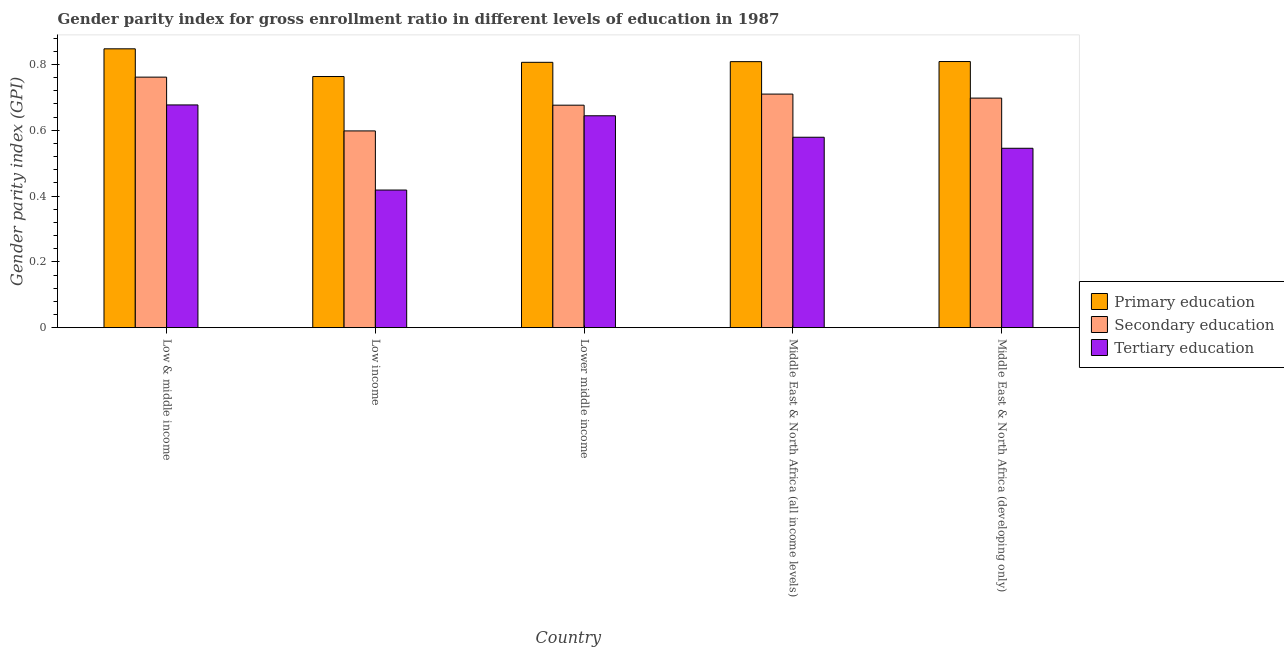How many different coloured bars are there?
Your answer should be very brief. 3. Are the number of bars per tick equal to the number of legend labels?
Your answer should be very brief. Yes. What is the label of the 3rd group of bars from the left?
Your answer should be very brief. Lower middle income. What is the gender parity index in secondary education in Low income?
Give a very brief answer. 0.6. Across all countries, what is the maximum gender parity index in secondary education?
Give a very brief answer. 0.76. Across all countries, what is the minimum gender parity index in secondary education?
Your answer should be very brief. 0.6. In which country was the gender parity index in tertiary education maximum?
Your answer should be very brief. Low & middle income. What is the total gender parity index in primary education in the graph?
Ensure brevity in your answer.  4.03. What is the difference between the gender parity index in primary education in Low income and that in Middle East & North Africa (all income levels)?
Keep it short and to the point. -0.05. What is the difference between the gender parity index in secondary education in Lower middle income and the gender parity index in tertiary education in Middle East & North Africa (developing only)?
Your answer should be very brief. 0.13. What is the average gender parity index in tertiary education per country?
Keep it short and to the point. 0.57. What is the difference between the gender parity index in secondary education and gender parity index in tertiary education in Low & middle income?
Provide a succinct answer. 0.08. In how many countries, is the gender parity index in primary education greater than 0.24000000000000002 ?
Ensure brevity in your answer.  5. What is the ratio of the gender parity index in secondary education in Low & middle income to that in Low income?
Your answer should be very brief. 1.27. Is the gender parity index in tertiary education in Lower middle income less than that in Middle East & North Africa (developing only)?
Give a very brief answer. No. Is the difference between the gender parity index in secondary education in Low income and Middle East & North Africa (developing only) greater than the difference between the gender parity index in tertiary education in Low income and Middle East & North Africa (developing only)?
Offer a very short reply. Yes. What is the difference between the highest and the second highest gender parity index in secondary education?
Make the answer very short. 0.05. What is the difference between the highest and the lowest gender parity index in primary education?
Provide a succinct answer. 0.08. What does the 2nd bar from the left in Low income represents?
Offer a terse response. Secondary education. What does the 2nd bar from the right in Middle East & North Africa (developing only) represents?
Keep it short and to the point. Secondary education. Is it the case that in every country, the sum of the gender parity index in primary education and gender parity index in secondary education is greater than the gender parity index in tertiary education?
Provide a short and direct response. Yes. Are all the bars in the graph horizontal?
Keep it short and to the point. No. What is the difference between two consecutive major ticks on the Y-axis?
Ensure brevity in your answer.  0.2. Does the graph contain any zero values?
Give a very brief answer. No. Where does the legend appear in the graph?
Your response must be concise. Center right. What is the title of the graph?
Ensure brevity in your answer.  Gender parity index for gross enrollment ratio in different levels of education in 1987. What is the label or title of the X-axis?
Your answer should be very brief. Country. What is the label or title of the Y-axis?
Offer a terse response. Gender parity index (GPI). What is the Gender parity index (GPI) of Primary education in Low & middle income?
Provide a short and direct response. 0.85. What is the Gender parity index (GPI) of Secondary education in Low & middle income?
Your response must be concise. 0.76. What is the Gender parity index (GPI) in Tertiary education in Low & middle income?
Offer a terse response. 0.68. What is the Gender parity index (GPI) in Primary education in Low income?
Your answer should be very brief. 0.76. What is the Gender parity index (GPI) in Secondary education in Low income?
Offer a very short reply. 0.6. What is the Gender parity index (GPI) in Tertiary education in Low income?
Provide a short and direct response. 0.42. What is the Gender parity index (GPI) in Primary education in Lower middle income?
Your answer should be compact. 0.81. What is the Gender parity index (GPI) of Secondary education in Lower middle income?
Give a very brief answer. 0.68. What is the Gender parity index (GPI) in Tertiary education in Lower middle income?
Offer a very short reply. 0.64. What is the Gender parity index (GPI) of Primary education in Middle East & North Africa (all income levels)?
Give a very brief answer. 0.81. What is the Gender parity index (GPI) of Secondary education in Middle East & North Africa (all income levels)?
Your answer should be compact. 0.71. What is the Gender parity index (GPI) in Tertiary education in Middle East & North Africa (all income levels)?
Offer a terse response. 0.58. What is the Gender parity index (GPI) in Primary education in Middle East & North Africa (developing only)?
Your answer should be very brief. 0.81. What is the Gender parity index (GPI) of Secondary education in Middle East & North Africa (developing only)?
Your response must be concise. 0.7. What is the Gender parity index (GPI) in Tertiary education in Middle East & North Africa (developing only)?
Offer a terse response. 0.55. Across all countries, what is the maximum Gender parity index (GPI) of Primary education?
Offer a terse response. 0.85. Across all countries, what is the maximum Gender parity index (GPI) of Secondary education?
Your response must be concise. 0.76. Across all countries, what is the maximum Gender parity index (GPI) in Tertiary education?
Provide a short and direct response. 0.68. Across all countries, what is the minimum Gender parity index (GPI) in Primary education?
Make the answer very short. 0.76. Across all countries, what is the minimum Gender parity index (GPI) in Secondary education?
Provide a short and direct response. 0.6. Across all countries, what is the minimum Gender parity index (GPI) in Tertiary education?
Ensure brevity in your answer.  0.42. What is the total Gender parity index (GPI) in Primary education in the graph?
Offer a very short reply. 4.03. What is the total Gender parity index (GPI) in Secondary education in the graph?
Provide a short and direct response. 3.44. What is the total Gender parity index (GPI) of Tertiary education in the graph?
Provide a succinct answer. 2.86. What is the difference between the Gender parity index (GPI) in Primary education in Low & middle income and that in Low income?
Your response must be concise. 0.08. What is the difference between the Gender parity index (GPI) in Secondary education in Low & middle income and that in Low income?
Offer a very short reply. 0.16. What is the difference between the Gender parity index (GPI) of Tertiary education in Low & middle income and that in Low income?
Offer a terse response. 0.26. What is the difference between the Gender parity index (GPI) of Primary education in Low & middle income and that in Lower middle income?
Offer a terse response. 0.04. What is the difference between the Gender parity index (GPI) of Secondary education in Low & middle income and that in Lower middle income?
Ensure brevity in your answer.  0.09. What is the difference between the Gender parity index (GPI) in Tertiary education in Low & middle income and that in Lower middle income?
Your response must be concise. 0.03. What is the difference between the Gender parity index (GPI) of Primary education in Low & middle income and that in Middle East & North Africa (all income levels)?
Provide a short and direct response. 0.04. What is the difference between the Gender parity index (GPI) of Secondary education in Low & middle income and that in Middle East & North Africa (all income levels)?
Give a very brief answer. 0.05. What is the difference between the Gender parity index (GPI) of Tertiary education in Low & middle income and that in Middle East & North Africa (all income levels)?
Your answer should be very brief. 0.1. What is the difference between the Gender parity index (GPI) of Primary education in Low & middle income and that in Middle East & North Africa (developing only)?
Your answer should be compact. 0.04. What is the difference between the Gender parity index (GPI) of Secondary education in Low & middle income and that in Middle East & North Africa (developing only)?
Provide a succinct answer. 0.06. What is the difference between the Gender parity index (GPI) in Tertiary education in Low & middle income and that in Middle East & North Africa (developing only)?
Make the answer very short. 0.13. What is the difference between the Gender parity index (GPI) in Primary education in Low income and that in Lower middle income?
Your answer should be very brief. -0.04. What is the difference between the Gender parity index (GPI) in Secondary education in Low income and that in Lower middle income?
Make the answer very short. -0.08. What is the difference between the Gender parity index (GPI) of Tertiary education in Low income and that in Lower middle income?
Ensure brevity in your answer.  -0.23. What is the difference between the Gender parity index (GPI) in Primary education in Low income and that in Middle East & North Africa (all income levels)?
Your answer should be very brief. -0.05. What is the difference between the Gender parity index (GPI) in Secondary education in Low income and that in Middle East & North Africa (all income levels)?
Give a very brief answer. -0.11. What is the difference between the Gender parity index (GPI) in Tertiary education in Low income and that in Middle East & North Africa (all income levels)?
Provide a short and direct response. -0.16. What is the difference between the Gender parity index (GPI) of Primary education in Low income and that in Middle East & North Africa (developing only)?
Your answer should be very brief. -0.05. What is the difference between the Gender parity index (GPI) of Secondary education in Low income and that in Middle East & North Africa (developing only)?
Provide a short and direct response. -0.1. What is the difference between the Gender parity index (GPI) of Tertiary education in Low income and that in Middle East & North Africa (developing only)?
Offer a very short reply. -0.13. What is the difference between the Gender parity index (GPI) of Primary education in Lower middle income and that in Middle East & North Africa (all income levels)?
Your answer should be compact. -0. What is the difference between the Gender parity index (GPI) in Secondary education in Lower middle income and that in Middle East & North Africa (all income levels)?
Provide a succinct answer. -0.03. What is the difference between the Gender parity index (GPI) in Tertiary education in Lower middle income and that in Middle East & North Africa (all income levels)?
Ensure brevity in your answer.  0.07. What is the difference between the Gender parity index (GPI) in Primary education in Lower middle income and that in Middle East & North Africa (developing only)?
Ensure brevity in your answer.  -0. What is the difference between the Gender parity index (GPI) of Secondary education in Lower middle income and that in Middle East & North Africa (developing only)?
Provide a succinct answer. -0.02. What is the difference between the Gender parity index (GPI) of Tertiary education in Lower middle income and that in Middle East & North Africa (developing only)?
Your answer should be very brief. 0.1. What is the difference between the Gender parity index (GPI) in Primary education in Middle East & North Africa (all income levels) and that in Middle East & North Africa (developing only)?
Give a very brief answer. -0. What is the difference between the Gender parity index (GPI) in Secondary education in Middle East & North Africa (all income levels) and that in Middle East & North Africa (developing only)?
Offer a terse response. 0.01. What is the difference between the Gender parity index (GPI) of Tertiary education in Middle East & North Africa (all income levels) and that in Middle East & North Africa (developing only)?
Offer a very short reply. 0.03. What is the difference between the Gender parity index (GPI) of Primary education in Low & middle income and the Gender parity index (GPI) of Secondary education in Low income?
Offer a terse response. 0.25. What is the difference between the Gender parity index (GPI) of Primary education in Low & middle income and the Gender parity index (GPI) of Tertiary education in Low income?
Your response must be concise. 0.43. What is the difference between the Gender parity index (GPI) of Secondary education in Low & middle income and the Gender parity index (GPI) of Tertiary education in Low income?
Give a very brief answer. 0.34. What is the difference between the Gender parity index (GPI) of Primary education in Low & middle income and the Gender parity index (GPI) of Secondary education in Lower middle income?
Your answer should be compact. 0.17. What is the difference between the Gender parity index (GPI) in Primary education in Low & middle income and the Gender parity index (GPI) in Tertiary education in Lower middle income?
Your response must be concise. 0.2. What is the difference between the Gender parity index (GPI) in Secondary education in Low & middle income and the Gender parity index (GPI) in Tertiary education in Lower middle income?
Give a very brief answer. 0.12. What is the difference between the Gender parity index (GPI) of Primary education in Low & middle income and the Gender parity index (GPI) of Secondary education in Middle East & North Africa (all income levels)?
Your answer should be compact. 0.14. What is the difference between the Gender parity index (GPI) of Primary education in Low & middle income and the Gender parity index (GPI) of Tertiary education in Middle East & North Africa (all income levels)?
Provide a short and direct response. 0.27. What is the difference between the Gender parity index (GPI) of Secondary education in Low & middle income and the Gender parity index (GPI) of Tertiary education in Middle East & North Africa (all income levels)?
Offer a terse response. 0.18. What is the difference between the Gender parity index (GPI) in Primary education in Low & middle income and the Gender parity index (GPI) in Secondary education in Middle East & North Africa (developing only)?
Ensure brevity in your answer.  0.15. What is the difference between the Gender parity index (GPI) in Primary education in Low & middle income and the Gender parity index (GPI) in Tertiary education in Middle East & North Africa (developing only)?
Give a very brief answer. 0.3. What is the difference between the Gender parity index (GPI) of Secondary education in Low & middle income and the Gender parity index (GPI) of Tertiary education in Middle East & North Africa (developing only)?
Your answer should be very brief. 0.22. What is the difference between the Gender parity index (GPI) in Primary education in Low income and the Gender parity index (GPI) in Secondary education in Lower middle income?
Your answer should be compact. 0.09. What is the difference between the Gender parity index (GPI) in Primary education in Low income and the Gender parity index (GPI) in Tertiary education in Lower middle income?
Provide a succinct answer. 0.12. What is the difference between the Gender parity index (GPI) of Secondary education in Low income and the Gender parity index (GPI) of Tertiary education in Lower middle income?
Make the answer very short. -0.05. What is the difference between the Gender parity index (GPI) in Primary education in Low income and the Gender parity index (GPI) in Secondary education in Middle East & North Africa (all income levels)?
Provide a short and direct response. 0.05. What is the difference between the Gender parity index (GPI) in Primary education in Low income and the Gender parity index (GPI) in Tertiary education in Middle East & North Africa (all income levels)?
Offer a very short reply. 0.18. What is the difference between the Gender parity index (GPI) of Secondary education in Low income and the Gender parity index (GPI) of Tertiary education in Middle East & North Africa (all income levels)?
Keep it short and to the point. 0.02. What is the difference between the Gender parity index (GPI) in Primary education in Low income and the Gender parity index (GPI) in Secondary education in Middle East & North Africa (developing only)?
Offer a very short reply. 0.07. What is the difference between the Gender parity index (GPI) of Primary education in Low income and the Gender parity index (GPI) of Tertiary education in Middle East & North Africa (developing only)?
Keep it short and to the point. 0.22. What is the difference between the Gender parity index (GPI) in Secondary education in Low income and the Gender parity index (GPI) in Tertiary education in Middle East & North Africa (developing only)?
Keep it short and to the point. 0.05. What is the difference between the Gender parity index (GPI) of Primary education in Lower middle income and the Gender parity index (GPI) of Secondary education in Middle East & North Africa (all income levels)?
Make the answer very short. 0.1. What is the difference between the Gender parity index (GPI) in Primary education in Lower middle income and the Gender parity index (GPI) in Tertiary education in Middle East & North Africa (all income levels)?
Your answer should be compact. 0.23. What is the difference between the Gender parity index (GPI) of Secondary education in Lower middle income and the Gender parity index (GPI) of Tertiary education in Middle East & North Africa (all income levels)?
Keep it short and to the point. 0.1. What is the difference between the Gender parity index (GPI) of Primary education in Lower middle income and the Gender parity index (GPI) of Secondary education in Middle East & North Africa (developing only)?
Ensure brevity in your answer.  0.11. What is the difference between the Gender parity index (GPI) in Primary education in Lower middle income and the Gender parity index (GPI) in Tertiary education in Middle East & North Africa (developing only)?
Provide a succinct answer. 0.26. What is the difference between the Gender parity index (GPI) of Secondary education in Lower middle income and the Gender parity index (GPI) of Tertiary education in Middle East & North Africa (developing only)?
Your response must be concise. 0.13. What is the difference between the Gender parity index (GPI) of Primary education in Middle East & North Africa (all income levels) and the Gender parity index (GPI) of Secondary education in Middle East & North Africa (developing only)?
Provide a short and direct response. 0.11. What is the difference between the Gender parity index (GPI) in Primary education in Middle East & North Africa (all income levels) and the Gender parity index (GPI) in Tertiary education in Middle East & North Africa (developing only)?
Provide a succinct answer. 0.26. What is the difference between the Gender parity index (GPI) in Secondary education in Middle East & North Africa (all income levels) and the Gender parity index (GPI) in Tertiary education in Middle East & North Africa (developing only)?
Ensure brevity in your answer.  0.16. What is the average Gender parity index (GPI) of Primary education per country?
Ensure brevity in your answer.  0.81. What is the average Gender parity index (GPI) in Secondary education per country?
Provide a short and direct response. 0.69. What is the average Gender parity index (GPI) in Tertiary education per country?
Provide a short and direct response. 0.57. What is the difference between the Gender parity index (GPI) in Primary education and Gender parity index (GPI) in Secondary education in Low & middle income?
Make the answer very short. 0.09. What is the difference between the Gender parity index (GPI) in Primary education and Gender parity index (GPI) in Tertiary education in Low & middle income?
Provide a short and direct response. 0.17. What is the difference between the Gender parity index (GPI) of Secondary education and Gender parity index (GPI) of Tertiary education in Low & middle income?
Offer a very short reply. 0.08. What is the difference between the Gender parity index (GPI) in Primary education and Gender parity index (GPI) in Secondary education in Low income?
Offer a very short reply. 0.17. What is the difference between the Gender parity index (GPI) of Primary education and Gender parity index (GPI) of Tertiary education in Low income?
Provide a succinct answer. 0.34. What is the difference between the Gender parity index (GPI) in Secondary education and Gender parity index (GPI) in Tertiary education in Low income?
Your answer should be compact. 0.18. What is the difference between the Gender parity index (GPI) in Primary education and Gender parity index (GPI) in Secondary education in Lower middle income?
Your answer should be very brief. 0.13. What is the difference between the Gender parity index (GPI) of Primary education and Gender parity index (GPI) of Tertiary education in Lower middle income?
Offer a very short reply. 0.16. What is the difference between the Gender parity index (GPI) in Secondary education and Gender parity index (GPI) in Tertiary education in Lower middle income?
Your answer should be very brief. 0.03. What is the difference between the Gender parity index (GPI) of Primary education and Gender parity index (GPI) of Secondary education in Middle East & North Africa (all income levels)?
Make the answer very short. 0.1. What is the difference between the Gender parity index (GPI) of Primary education and Gender parity index (GPI) of Tertiary education in Middle East & North Africa (all income levels)?
Provide a succinct answer. 0.23. What is the difference between the Gender parity index (GPI) of Secondary education and Gender parity index (GPI) of Tertiary education in Middle East & North Africa (all income levels)?
Offer a very short reply. 0.13. What is the difference between the Gender parity index (GPI) in Primary education and Gender parity index (GPI) in Secondary education in Middle East & North Africa (developing only)?
Give a very brief answer. 0.11. What is the difference between the Gender parity index (GPI) in Primary education and Gender parity index (GPI) in Tertiary education in Middle East & North Africa (developing only)?
Ensure brevity in your answer.  0.26. What is the difference between the Gender parity index (GPI) of Secondary education and Gender parity index (GPI) of Tertiary education in Middle East & North Africa (developing only)?
Your answer should be very brief. 0.15. What is the ratio of the Gender parity index (GPI) in Primary education in Low & middle income to that in Low income?
Make the answer very short. 1.11. What is the ratio of the Gender parity index (GPI) of Secondary education in Low & middle income to that in Low income?
Offer a very short reply. 1.27. What is the ratio of the Gender parity index (GPI) in Tertiary education in Low & middle income to that in Low income?
Offer a terse response. 1.62. What is the ratio of the Gender parity index (GPI) in Primary education in Low & middle income to that in Lower middle income?
Your answer should be very brief. 1.05. What is the ratio of the Gender parity index (GPI) in Secondary education in Low & middle income to that in Lower middle income?
Your answer should be compact. 1.13. What is the ratio of the Gender parity index (GPI) of Tertiary education in Low & middle income to that in Lower middle income?
Your response must be concise. 1.05. What is the ratio of the Gender parity index (GPI) of Primary education in Low & middle income to that in Middle East & North Africa (all income levels)?
Your answer should be compact. 1.05. What is the ratio of the Gender parity index (GPI) in Secondary education in Low & middle income to that in Middle East & North Africa (all income levels)?
Give a very brief answer. 1.07. What is the ratio of the Gender parity index (GPI) in Tertiary education in Low & middle income to that in Middle East & North Africa (all income levels)?
Your response must be concise. 1.17. What is the ratio of the Gender parity index (GPI) of Primary education in Low & middle income to that in Middle East & North Africa (developing only)?
Your response must be concise. 1.05. What is the ratio of the Gender parity index (GPI) of Secondary education in Low & middle income to that in Middle East & North Africa (developing only)?
Keep it short and to the point. 1.09. What is the ratio of the Gender parity index (GPI) in Tertiary education in Low & middle income to that in Middle East & North Africa (developing only)?
Ensure brevity in your answer.  1.24. What is the ratio of the Gender parity index (GPI) of Primary education in Low income to that in Lower middle income?
Ensure brevity in your answer.  0.95. What is the ratio of the Gender parity index (GPI) in Secondary education in Low income to that in Lower middle income?
Keep it short and to the point. 0.88. What is the ratio of the Gender parity index (GPI) of Tertiary education in Low income to that in Lower middle income?
Ensure brevity in your answer.  0.65. What is the ratio of the Gender parity index (GPI) of Primary education in Low income to that in Middle East & North Africa (all income levels)?
Offer a terse response. 0.94. What is the ratio of the Gender parity index (GPI) of Secondary education in Low income to that in Middle East & North Africa (all income levels)?
Ensure brevity in your answer.  0.84. What is the ratio of the Gender parity index (GPI) of Tertiary education in Low income to that in Middle East & North Africa (all income levels)?
Your response must be concise. 0.72. What is the ratio of the Gender parity index (GPI) of Primary education in Low income to that in Middle East & North Africa (developing only)?
Your response must be concise. 0.94. What is the ratio of the Gender parity index (GPI) of Secondary education in Low income to that in Middle East & North Africa (developing only)?
Keep it short and to the point. 0.86. What is the ratio of the Gender parity index (GPI) of Tertiary education in Low income to that in Middle East & North Africa (developing only)?
Offer a very short reply. 0.77. What is the ratio of the Gender parity index (GPI) in Secondary education in Lower middle income to that in Middle East & North Africa (all income levels)?
Your response must be concise. 0.95. What is the ratio of the Gender parity index (GPI) in Tertiary education in Lower middle income to that in Middle East & North Africa (all income levels)?
Ensure brevity in your answer.  1.11. What is the ratio of the Gender parity index (GPI) of Secondary education in Lower middle income to that in Middle East & North Africa (developing only)?
Make the answer very short. 0.97. What is the ratio of the Gender parity index (GPI) in Tertiary education in Lower middle income to that in Middle East & North Africa (developing only)?
Make the answer very short. 1.18. What is the ratio of the Gender parity index (GPI) in Secondary education in Middle East & North Africa (all income levels) to that in Middle East & North Africa (developing only)?
Your response must be concise. 1.02. What is the ratio of the Gender parity index (GPI) in Tertiary education in Middle East & North Africa (all income levels) to that in Middle East & North Africa (developing only)?
Keep it short and to the point. 1.06. What is the difference between the highest and the second highest Gender parity index (GPI) in Primary education?
Your answer should be compact. 0.04. What is the difference between the highest and the second highest Gender parity index (GPI) in Secondary education?
Your answer should be compact. 0.05. What is the difference between the highest and the second highest Gender parity index (GPI) in Tertiary education?
Offer a terse response. 0.03. What is the difference between the highest and the lowest Gender parity index (GPI) of Primary education?
Keep it short and to the point. 0.08. What is the difference between the highest and the lowest Gender parity index (GPI) of Secondary education?
Your response must be concise. 0.16. What is the difference between the highest and the lowest Gender parity index (GPI) of Tertiary education?
Offer a very short reply. 0.26. 